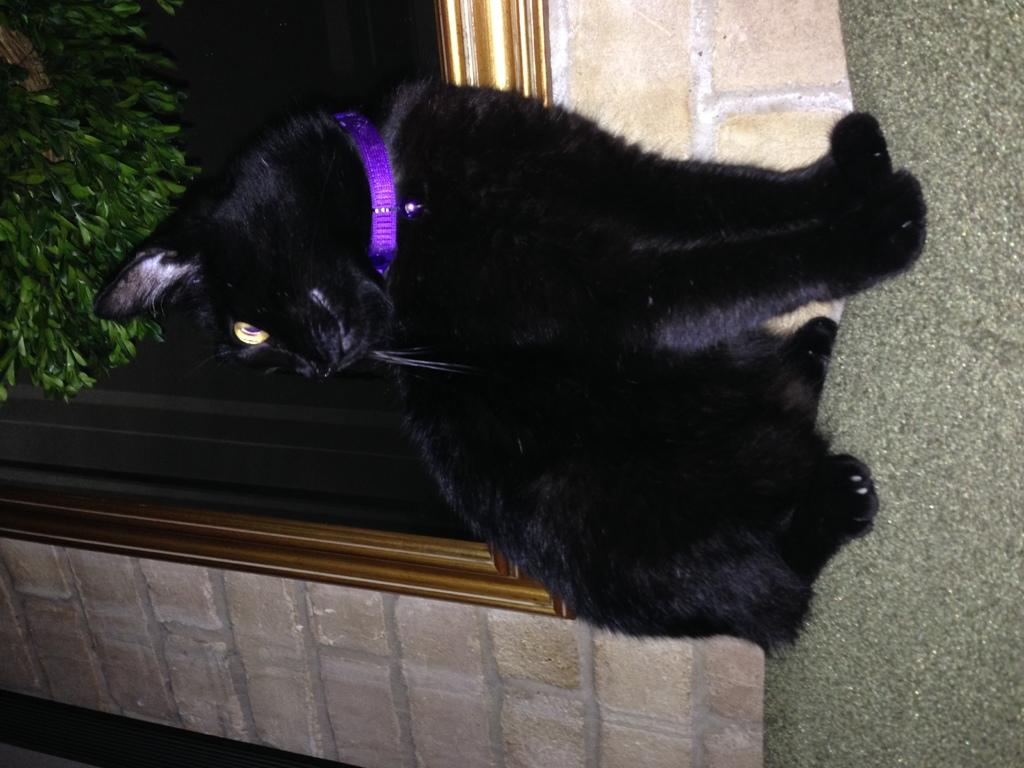What type of animal is in the image? There is a black color cat in the image. What is the cat standing on? The cat is on a light green color surface. What can be seen in the background of the image? There is a wall, a window, and leaves visible in the background of the image. What type of corn is growing in the image? There is no corn present in the image; it features a black color cat on a light green color surface with a wall, window, and leaves visible in the background. 